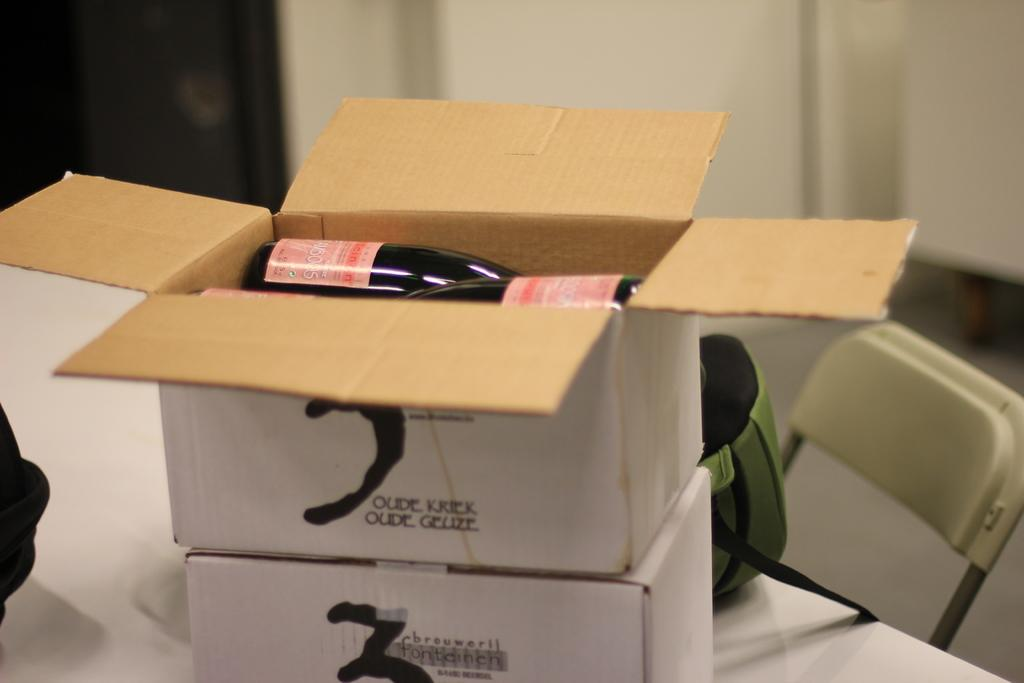<image>
Create a compact narrative representing the image presented. An open box that says "oude kriek oude geuze" on the side sits on top of another box. 